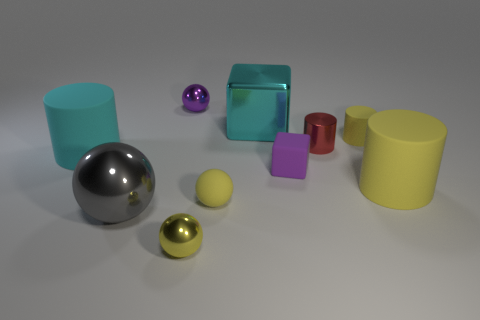What material is the sphere that is the same color as the small block?
Your answer should be very brief. Metal. What material is the tiny purple thing that is the same shape as the large gray thing?
Make the answer very short. Metal. How many other objects are there of the same material as the purple block?
Your response must be concise. 4. What number of big matte cylinders have the same color as the tiny block?
Ensure brevity in your answer.  0. There is a yellow cylinder that is behind the metal object right of the big cyan thing that is behind the cyan rubber cylinder; how big is it?
Provide a short and direct response. Small. What number of metal things are either blue cylinders or small things?
Keep it short and to the point. 3. There is a purple metallic object; is it the same shape as the object to the left of the big gray sphere?
Keep it short and to the point. No. Is the number of rubber cylinders right of the big cyan matte cylinder greater than the number of large cyan cubes that are to the right of the large gray metallic thing?
Your answer should be compact. Yes. Is there any other thing of the same color as the big shiny cube?
Provide a succinct answer. Yes. There is a tiny matte cube in front of the tiny metal object to the right of the purple rubber thing; is there a big cylinder that is to the right of it?
Provide a short and direct response. Yes. 